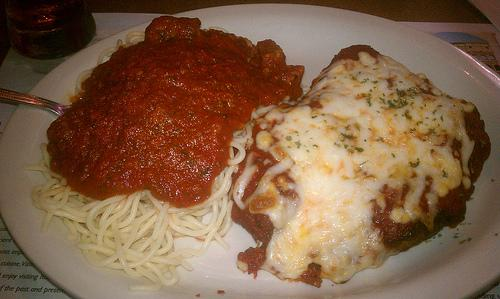In one sentence, describe the visual sentiment conveys by the image. A mouth-watering and inviting dish of spaghetti and chicken parmesan, ready to be enjoyed. How many types of sauce are visible on the pasta? One type, red spaghetti sauce. What type of utensil can be seen in the image and where it is located? A gray metal fork is located at the top-left side of the plate. Identify the type of food present on the plate in the image. Chicken parmesan with spaghetti and red sauce on a white plate. Mention the colors and objects related to the table setting. There is a white and light blue tablecloth, a white plate, a silver fork, and a bottom of a cup with a dark beverage. Describe any text present in the image. There are black words on white paper at the bottom-right corner. List down the toppings visible on the food on the plate. Melted cheese, oregano, green herb, and red pasta sauce. Explain the interaction between the fork and the food on the plate. The silver utensil, a fork, is partially inserted into the pasta, suggesting it is being used to eat the dish. Count the number of main food items on the plate. Two; spaghetti and chicken parmesan. Write a short phrase that can be used as an image caption, describing the meal. Delicious chicken parmesan and spaghetti on a white plate. What is the relation between the fork and the pasta? The fork is in the pasta. Is the cup with the dark beverage larger than the plate with food? The cup with the dark beverage is located at X:15 Y:33 with dimensions Width:83 Height:83, while the white plate with food is located at X:1 Y:2 with dimensions Width:497 Height:497. The plate is much larger than the cup, so the cup cannot be larger than the plate. Evaluate the overall visual quality of this image. Good quality, clear and sharp image What is the main ingredient of spaghetti and chicken parmesan? Pasta noodles Which object is interacting with the pasta? Gray metal fork What is the primary color of the plate? White What is the color of the tablecloth? White and light blue Is there any visible text in the image? Yes, "this is yummy spaghetti" on the white paper List the food items on the plate. Spaghetti with red sauce, chicken with melted cheese What is the word printed on the white paper? Yummy Is the tablecloth completely covered in spaghetti sauce? The tablecloth has dimensions Width:488 Height:488 and is located at X:10 Y:19, while the spaghetti sauce on noodles is located at X:133 Y:101 with dimensions Width:71 Height:71. The sauce is much smaller than the tablecloth and is located on the noodles, not entirely covering the tablecloth. Classify the text on the white paper as negative or positive sentiment. Positive sentiment Identify the presence of any unusual elements in the image. No unusual elements detected. What emotions does this image evoke? Hunger, satisfaction, comfort Describe the main subject of the image. Lunch consisting of spaghetti with red sauce, chicken with melted cheese and a fork on a white plate. What color is the sauce on the pasta? Red List the objects in the image and their coordinates. Red pasta sauce (X:47, Y:11), fork (X:4, Y:88), white plate (X:7, Y:1), melted cheese (X:274, Y:49) Is the black newsprint covering the entire plate of food? The black newsprint mentioned in the image is not covering the entire plate of food, but rather it is a small object located at X:11 Y:263 with dimensions Width:24 Height:24, which doesn't match the dimensions of the plate or food. Is there any green vegetable seasoning on the cheese? Yes, oregano Are the pasta noodles completely submerged in the red sauce? There is a portion of pasta with no sauce mentioned in the image at X:41 Y:193 with dimensions Width:190 Height:190, while the red sauce is located at X:48 Y:15 with dimensions Width:255 Height:255. Since there is pasta with no sauce, the pasta noodles are not completely submerged in the red sauce. Which object is the melted cheese on top of? Chicken Segment and label the different objects in the image. Pasta with red sauce - top area, white plate - middle area, melted cheese - right side, gray fork - left side Is the fork lying on top of the chicken parmesan? The fork has coordinates X:4 Y:88 and dimensions Width:70 Height:70, while the chicken parmesan is located at X:234 Y:43 with dimensions Width:264 Height:264. The fork and the chicken parmesan are not overlapping, so the fork is not lying on top of the dish. Does the green herb completely cover the surface of the meat? The green herb mentioned in the image has dimensions Width:71 Height:71, while the meat on the plate has dimensions Width:260 Height:260. Thus, the herb does not cover the whole surface of the meat. 